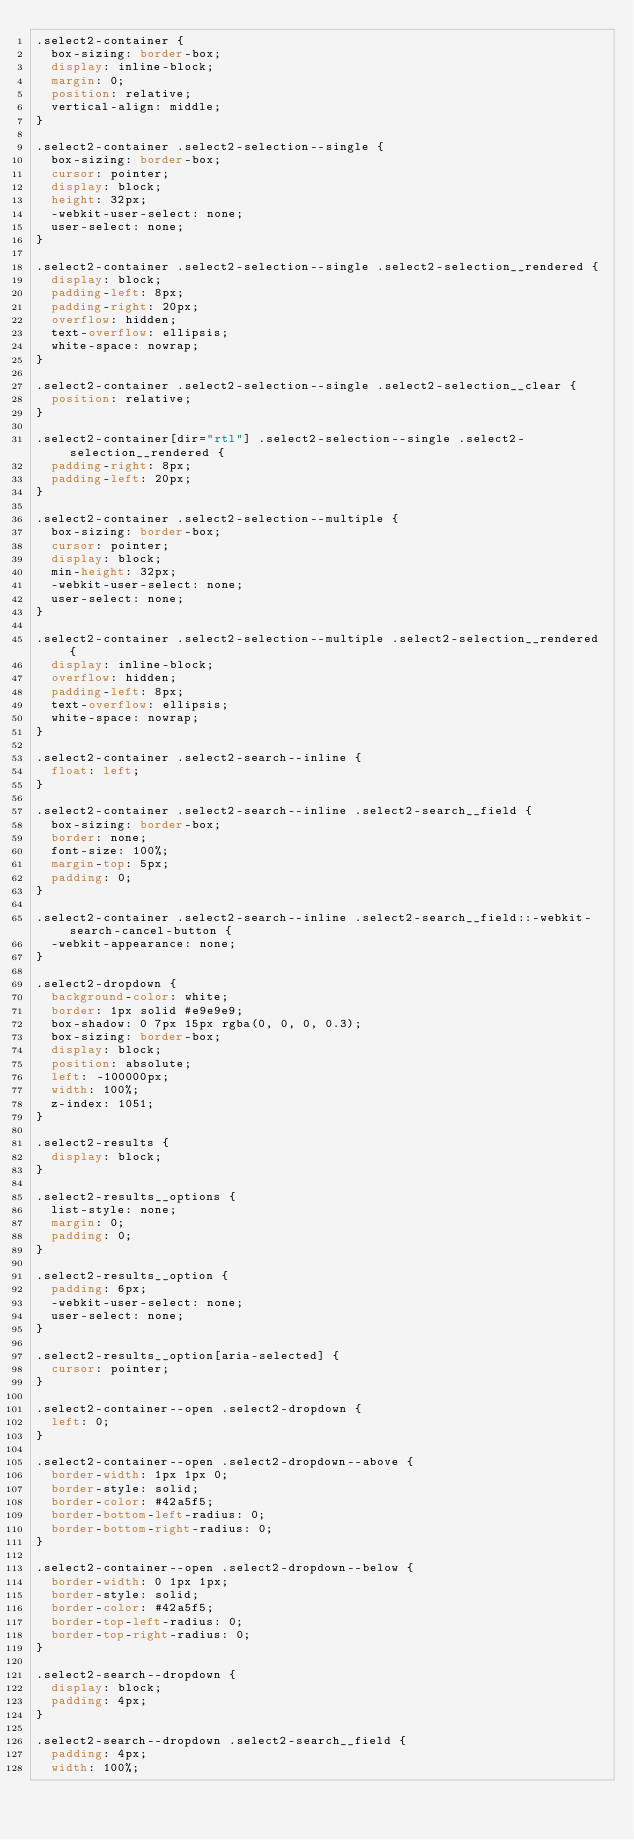Convert code to text. <code><loc_0><loc_0><loc_500><loc_500><_CSS_>.select2-container {
  box-sizing: border-box;
  display: inline-block;
  margin: 0;
  position: relative;
  vertical-align: middle;
}

.select2-container .select2-selection--single {
  box-sizing: border-box;
  cursor: pointer;
  display: block;
  height: 32px;
  -webkit-user-select: none;
  user-select: none;
}

.select2-container .select2-selection--single .select2-selection__rendered {
  display: block;
  padding-left: 8px;
  padding-right: 20px;
  overflow: hidden;
  text-overflow: ellipsis;
  white-space: nowrap;
}

.select2-container .select2-selection--single .select2-selection__clear {
  position: relative;
}

.select2-container[dir="rtl"] .select2-selection--single .select2-selection__rendered {
  padding-right: 8px;
  padding-left: 20px;
}

.select2-container .select2-selection--multiple {
  box-sizing: border-box;
  cursor: pointer;
  display: block;
  min-height: 32px;
  -webkit-user-select: none;
  user-select: none;
}

.select2-container .select2-selection--multiple .select2-selection__rendered {
  display: inline-block;
  overflow: hidden;
  padding-left: 8px;
  text-overflow: ellipsis;
  white-space: nowrap;
}

.select2-container .select2-search--inline {
  float: left;
}

.select2-container .select2-search--inline .select2-search__field {
  box-sizing: border-box;
  border: none;
  font-size: 100%;
  margin-top: 5px;
  padding: 0;
}

.select2-container .select2-search--inline .select2-search__field::-webkit-search-cancel-button {
  -webkit-appearance: none;
}

.select2-dropdown {
  background-color: white;
  border: 1px solid #e9e9e9;
  box-shadow: 0 7px 15px rgba(0, 0, 0, 0.3);
  box-sizing: border-box;
  display: block;
  position: absolute;
  left: -100000px;
  width: 100%;
  z-index: 1051;
}

.select2-results {
  display: block;
}

.select2-results__options {
  list-style: none;
  margin: 0;
  padding: 0;
}

.select2-results__option {
  padding: 6px;
  -webkit-user-select: none;
  user-select: none;
}

.select2-results__option[aria-selected] {
  cursor: pointer;
}

.select2-container--open .select2-dropdown {
  left: 0;
}

.select2-container--open .select2-dropdown--above {
  border-width: 1px 1px 0;
  border-style: solid;
  border-color: #42a5f5;
  border-bottom-left-radius: 0;
  border-bottom-right-radius: 0;
}

.select2-container--open .select2-dropdown--below {
  border-width: 0 1px 1px;
  border-style: solid;
  border-color: #42a5f5;
  border-top-left-radius: 0;
  border-top-right-radius: 0;
}

.select2-search--dropdown {
  display: block;
  padding: 4px;
}

.select2-search--dropdown .select2-search__field {
  padding: 4px;
  width: 100%;</code> 